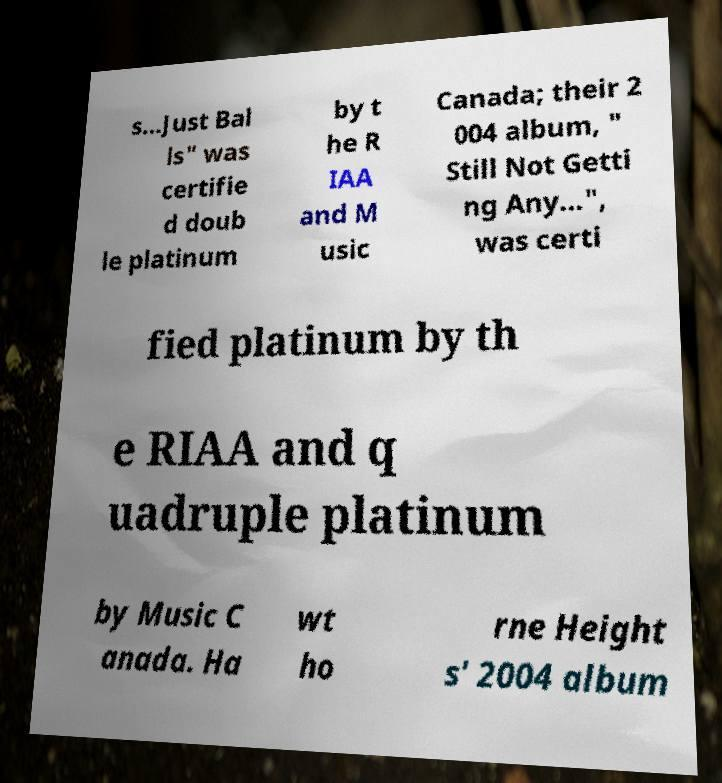Can you accurately transcribe the text from the provided image for me? s...Just Bal ls" was certifie d doub le platinum by t he R IAA and M usic Canada; their 2 004 album, " Still Not Getti ng Any...", was certi fied platinum by th e RIAA and q uadruple platinum by Music C anada. Ha wt ho rne Height s' 2004 album 